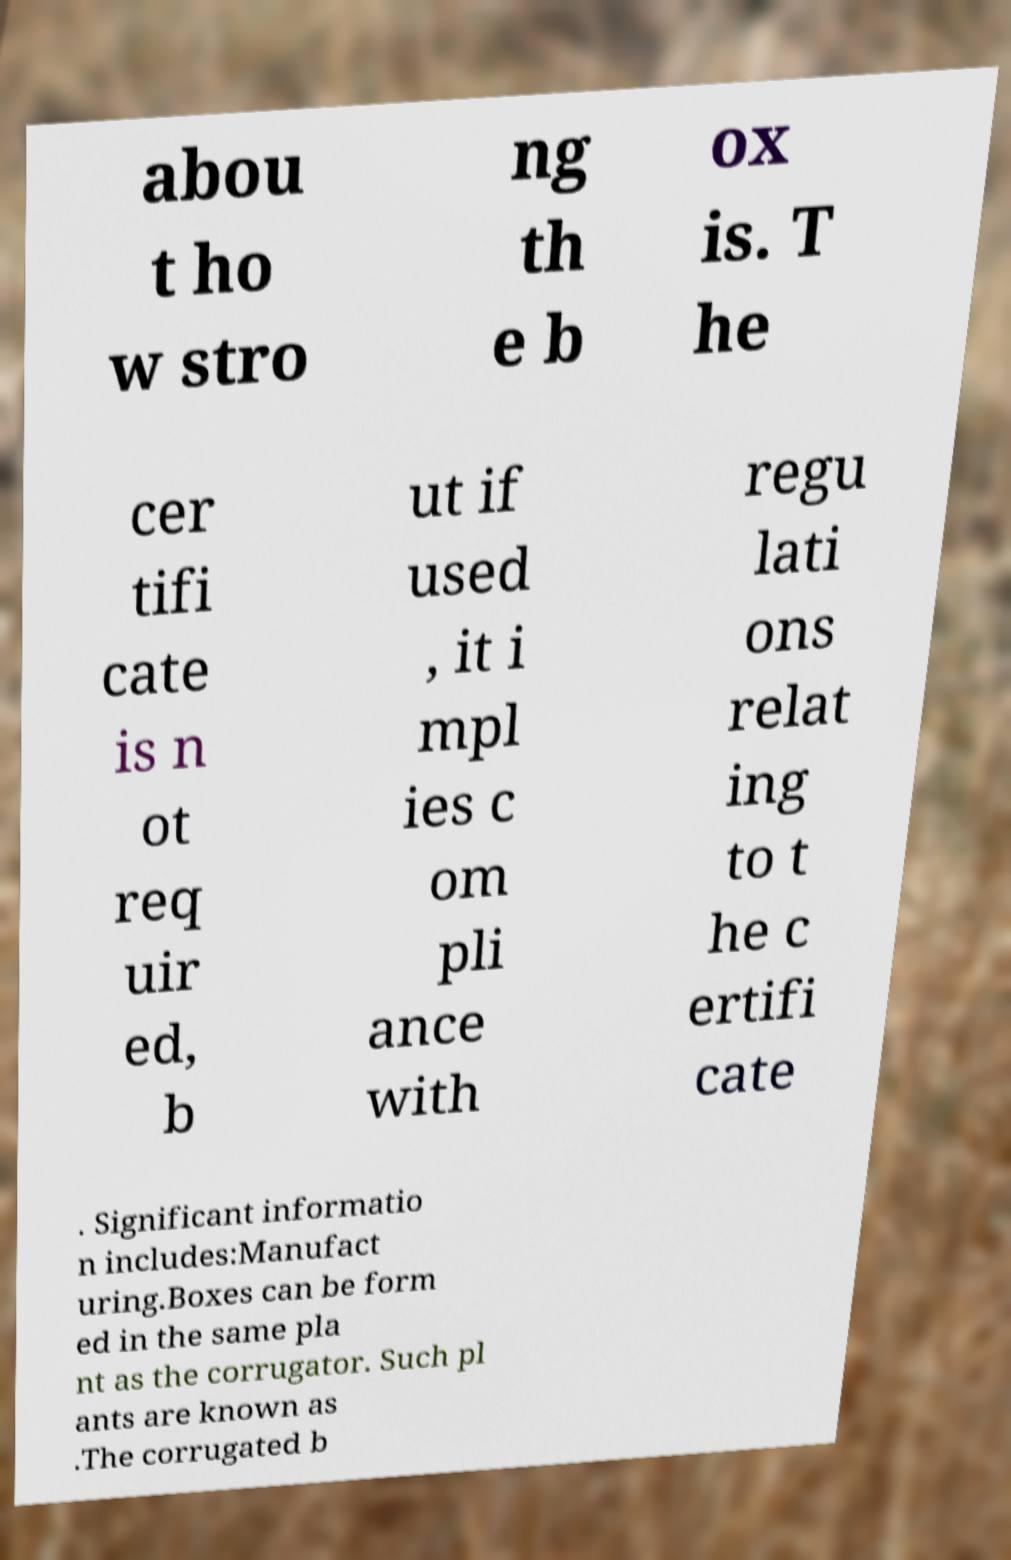What messages or text are displayed in this image? I need them in a readable, typed format. abou t ho w stro ng th e b ox is. T he cer tifi cate is n ot req uir ed, b ut if used , it i mpl ies c om pli ance with regu lati ons relat ing to t he c ertifi cate . Significant informatio n includes:Manufact uring.Boxes can be form ed in the same pla nt as the corrugator. Such pl ants are known as .The corrugated b 